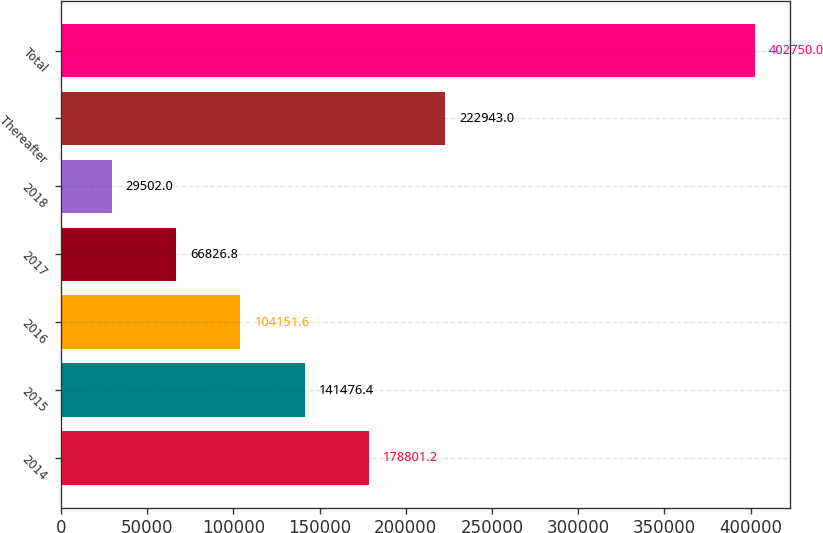Convert chart. <chart><loc_0><loc_0><loc_500><loc_500><bar_chart><fcel>2014<fcel>2015<fcel>2016<fcel>2017<fcel>2018<fcel>Thereafter<fcel>Total<nl><fcel>178801<fcel>141476<fcel>104152<fcel>66826.8<fcel>29502<fcel>222943<fcel>402750<nl></chart> 